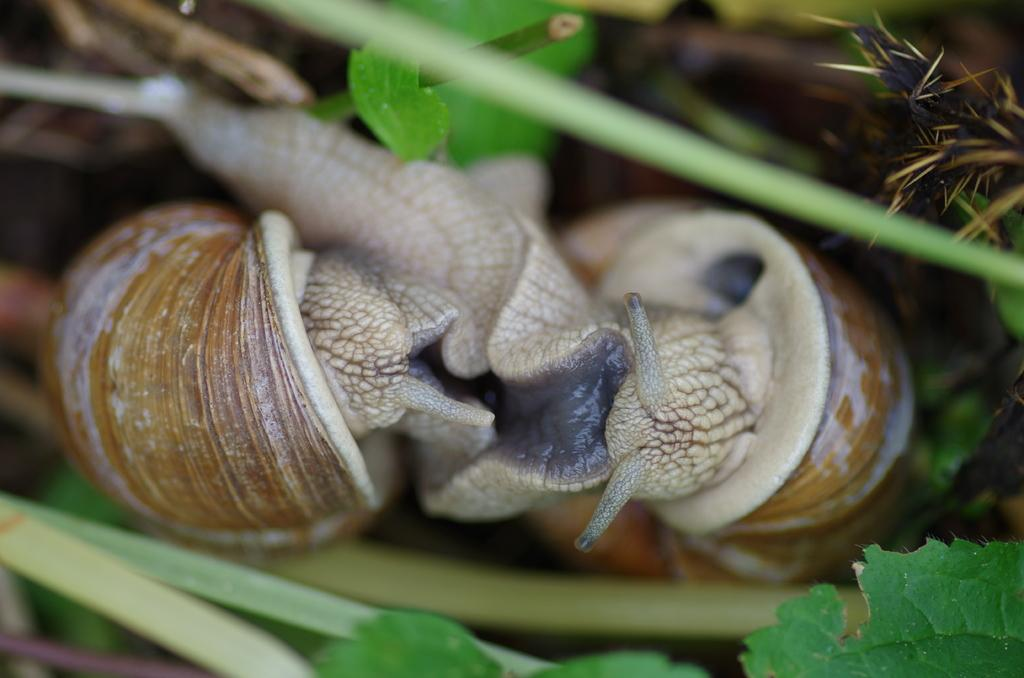What type of animals are present in the image? There are snails in the image. What other living organisms can be seen in the image? There are plants in the image. What type of tool is being used by the snail in the image? There is no tool present in the image, as it features snails and plants. 